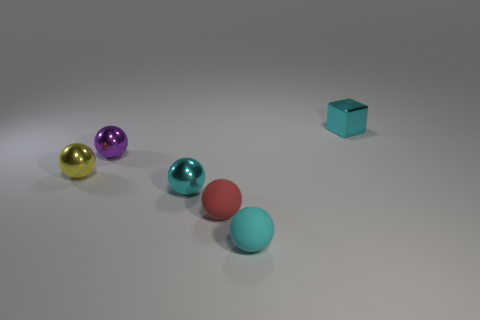Subtract all yellow spheres. How many spheres are left? 4 Subtract all tiny purple shiny balls. How many balls are left? 4 Subtract all purple spheres. Subtract all purple cubes. How many spheres are left? 4 Add 1 tiny blue metallic objects. How many objects exist? 7 Subtract all blocks. How many objects are left? 5 Subtract all small yellow rubber balls. Subtract all purple balls. How many objects are left? 5 Add 6 tiny yellow objects. How many tiny yellow objects are left? 7 Add 1 matte spheres. How many matte spheres exist? 3 Subtract 0 yellow cylinders. How many objects are left? 6 